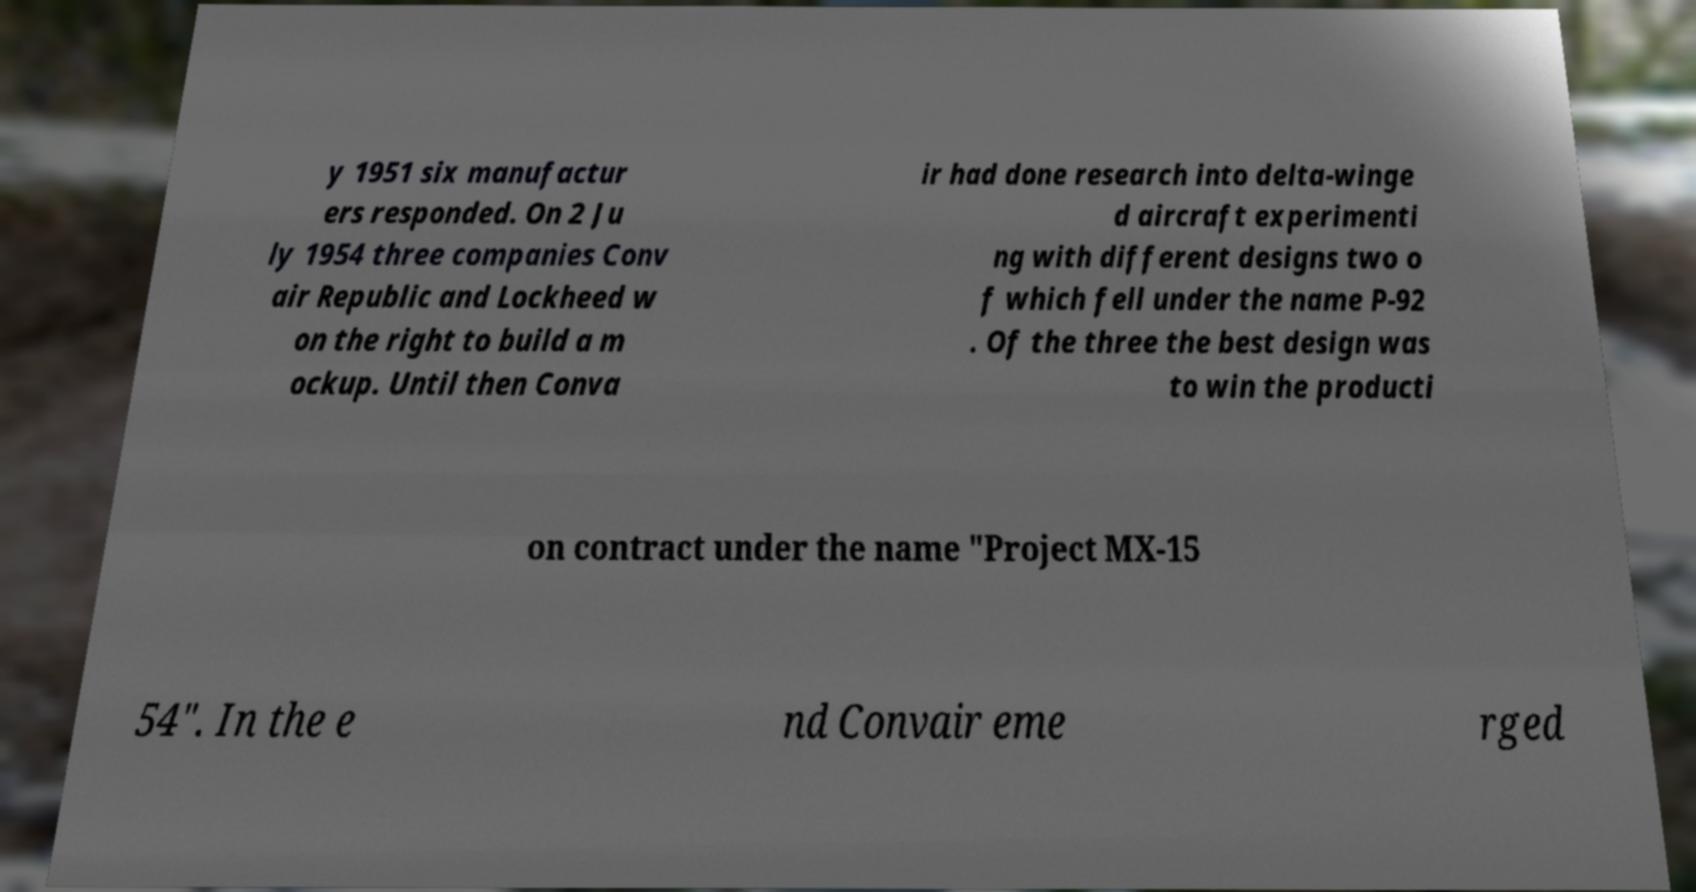For documentation purposes, I need the text within this image transcribed. Could you provide that? y 1951 six manufactur ers responded. On 2 Ju ly 1954 three companies Conv air Republic and Lockheed w on the right to build a m ockup. Until then Conva ir had done research into delta-winge d aircraft experimenti ng with different designs two o f which fell under the name P-92 . Of the three the best design was to win the producti on contract under the name "Project MX-15 54". In the e nd Convair eme rged 